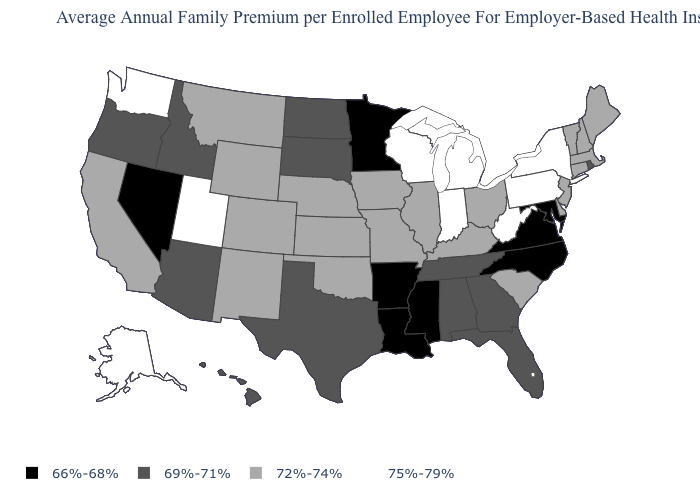What is the value of Montana?
Write a very short answer. 72%-74%. What is the value of South Carolina?
Keep it brief. 72%-74%. Is the legend a continuous bar?
Be succinct. No. What is the value of Massachusetts?
Quick response, please. 72%-74%. Which states have the lowest value in the USA?
Keep it brief. Arkansas, Louisiana, Maryland, Minnesota, Mississippi, Nevada, North Carolina, Virginia. What is the value of Montana?
Write a very short answer. 72%-74%. Does Nevada have a lower value than Virginia?
Concise answer only. No. Which states have the highest value in the USA?
Short answer required. Alaska, Indiana, Michigan, New York, Pennsylvania, Utah, Washington, West Virginia, Wisconsin. Which states hav the highest value in the Northeast?
Give a very brief answer. New York, Pennsylvania. What is the value of Missouri?
Be succinct. 72%-74%. Is the legend a continuous bar?
Write a very short answer. No. What is the value of Wisconsin?
Give a very brief answer. 75%-79%. Is the legend a continuous bar?
Keep it brief. No. What is the value of Oklahoma?
Quick response, please. 72%-74%. Does the map have missing data?
Be succinct. No. 